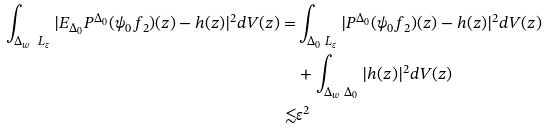<formula> <loc_0><loc_0><loc_500><loc_500>\int _ { \Delta _ { w } \ L _ { \varepsilon } } | E _ { \Delta _ { 0 } } P ^ { \Delta _ { 0 } } ( \psi _ { 0 } f _ { 2 } ) ( z ) - h ( z ) | ^ { 2 } d V ( z ) = & \int _ { \Delta _ { 0 } \ L _ { \varepsilon } } | P ^ { \Delta _ { 0 } } ( \psi _ { 0 } f _ { 2 } ) ( z ) - h ( z ) | ^ { 2 } d V ( z ) \\ & + \int _ { \Delta _ { w } \ \Delta _ { 0 } } | h ( z ) | ^ { 2 } d V ( z ) \\ \lesssim & \varepsilon ^ { 2 }</formula> 